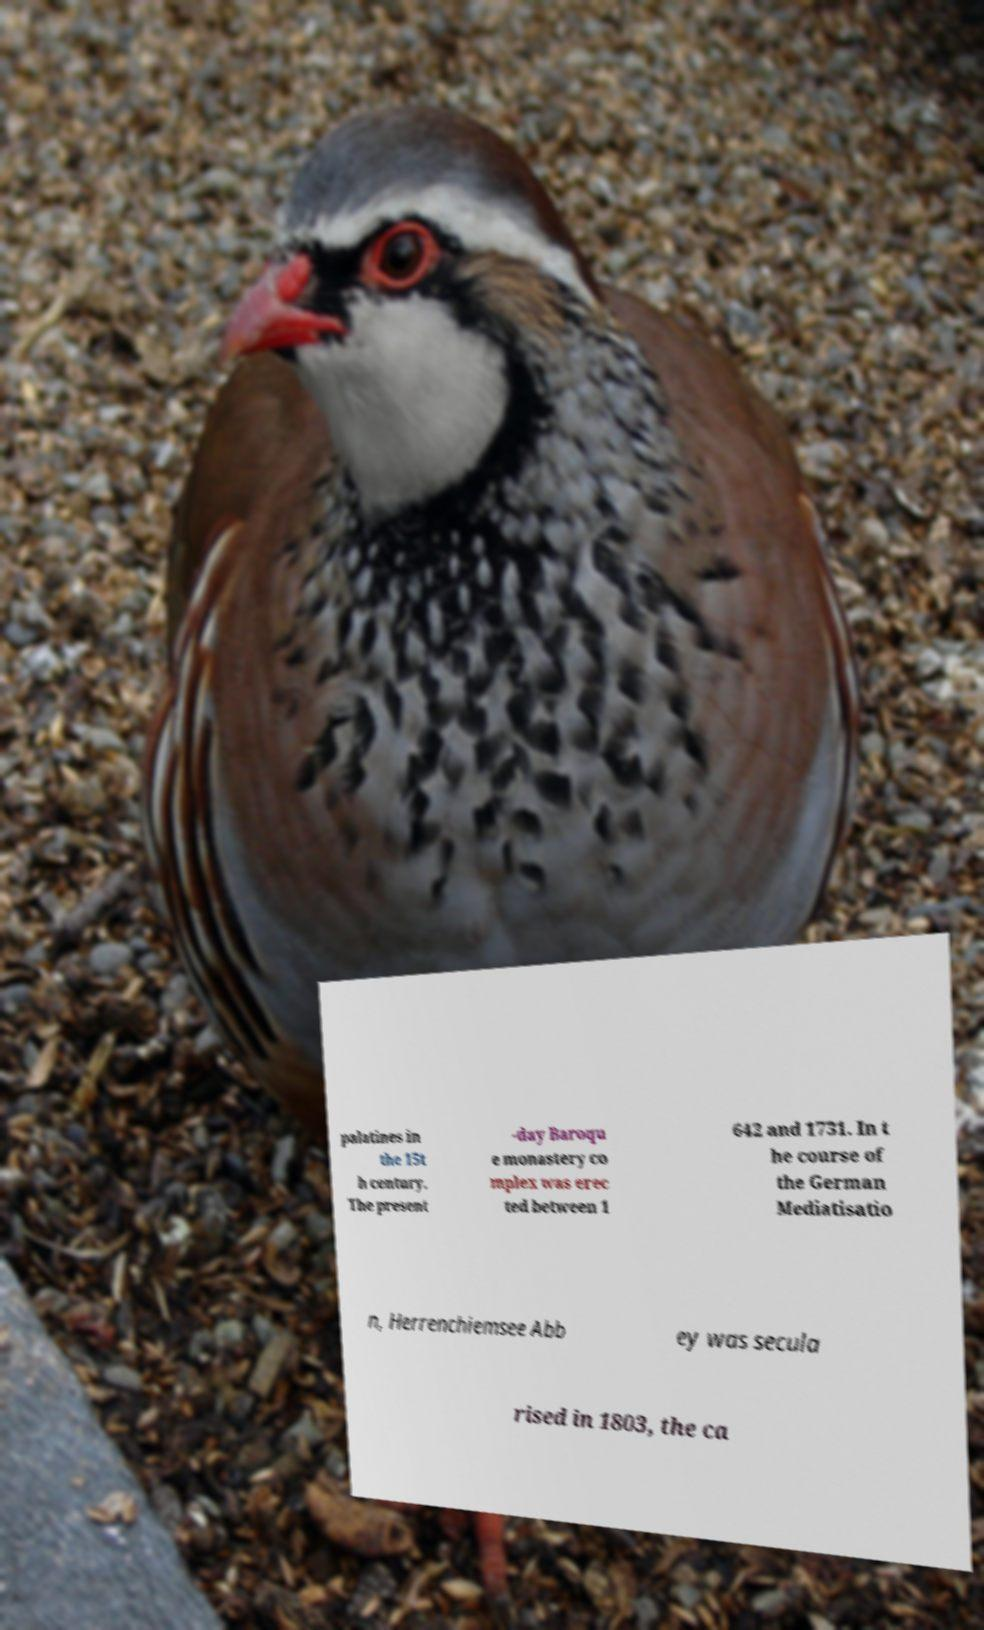What messages or text are displayed in this image? I need them in a readable, typed format. palatines in the 15t h century. The present -day Baroqu e monastery co mplex was erec ted between 1 642 and 1731. In t he course of the German Mediatisatio n, Herrenchiemsee Abb ey was secula rised in 1803, the ca 